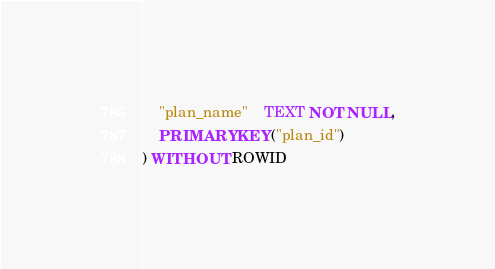<code> <loc_0><loc_0><loc_500><loc_500><_SQL_>	"plan_name"	TEXT NOT NULL,
	PRIMARY KEY("plan_id")
) WITHOUT ROWID</code> 